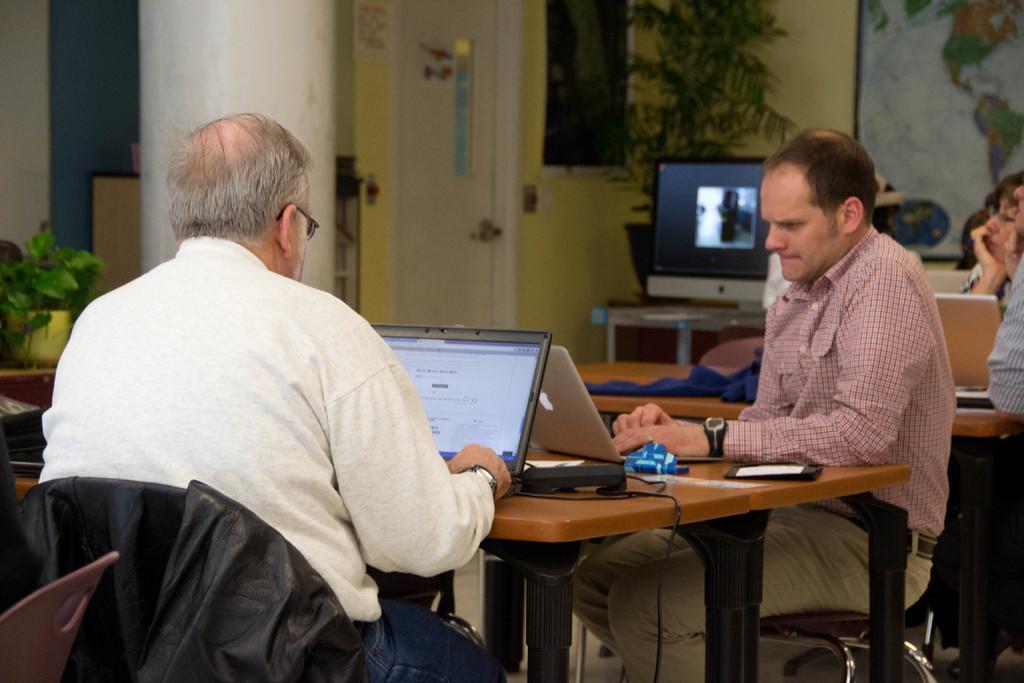In one or two sentences, can you explain what this image depicts? This pictures of inside the room. In the center we can see a man sitting on the chair and working on laptop. On the left there is a man wearing white color shirt, sitting on the chair and working on a laptop. In the right corner there are group of persons sitting on the chairs and there is a table at the top of which a monitor is placed. In the background we can see a pillar, a house plant, a door and a picture of a map hanging on the wall. 